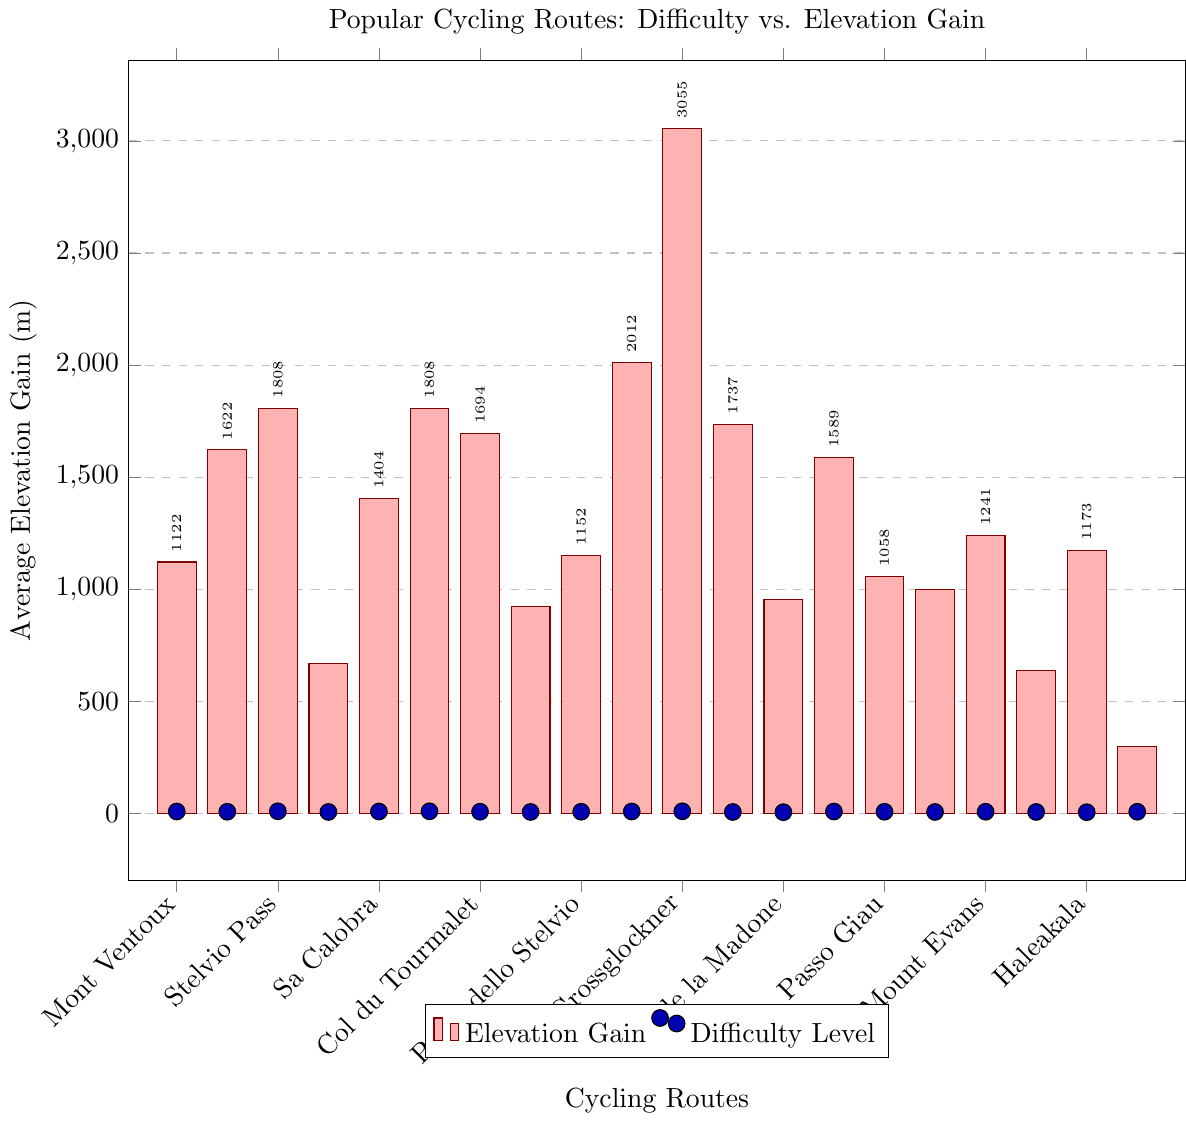What's the route with the highest average elevation gain? The route with the highest bar in the plot represents the highest average elevation gain. It is the “Haleakala” route marked with a height corresponding to 3055 meters.
Answer: Haleakala Which route has the least average elevation gain, and what is its difficulty level? The route with the smallest bar in the plot represents the least average elevation gain. This is the "Hardknott Pass" with an elevation gain of 298 meters. The associated mark shows a difficulty level of 8.
Answer: Hardknott Pass, 8 Compare the elevation gain of Mount Evans and Col de la Bonette. Which one has a higher elevation gain? By comparing the heights of the bars for Mount Evans and Col de la Bonette, Mount Evans has a higher elevation gain at 2012 meters compared to Col de la Bonette at 1589 meters.
Answer: Mount Evans What is the sum of the average elevation gains for the highest and lowest difficulty level routes? The highest difficulty level is 10, and has multiple routes: Stelvio Pass, Passo dello Stelvio, and Haleakala. We'll choose Haleakala for maximum elevation gain of 3055 meters. The lowest difficulty level represented is 6 with routes Axamer Lizum and Mount Diablo. We'll choose Mount Diablo with an elevation gain of 1173 meters. Sum = 3055 + 1173 = 4228 meters.
Answer: 4228 meters Which route with difficulty level 7 has the highest average elevation gain? Among the routes marked with a difficulty level of 7, the one with the tallest bar represents the highest elevation gain. Examining the plot, Mount Lemmon stands out with an elevation gain of 1737 meters.
Answer: Mount Lemmon Does the Stelvio Pass have the same elevation gain in both Italy and the specified one, and what is it? Observing the bars for "Stelvio Pass" and "Passo dello Stelvio" (both in Italy), both show the same elevation height, which is 1808 meters.
Answer: Yes, 1808 meters Compare the elevations of three routes with a difficulty level of 9 and identify the one with the lowest elevation gain. The three routes with a difficulty level of 9 are Alpe d'Huez, Col du Tourmalet, and Col de la Bonette. Their elevation gains are 1122m, 1404m, and 1589m respectively. Alpe d'Huez has the lowest elevation gain among them.
Answer: Alpe d'Huez For the route Grossglockner, what is the difference in meters between its elevation gain and the maximum elevation gain in the dataset? Grossglockner's elevation gain is 1694 meters. The maximum elevation gain in the dataset is Haleakala with 3055 meters. The difference is 3055 - 1694 = 1361 meters.
Answer: 1361 meters How many routes have an average elevation gain above 1600 meters, and what are their names? By examining the bars taller than the line marking 1600 meters, we find four routes: Mont Ventoux, Stelvio Pass (Italy), Mount Evans, Haleakala, and Mount Lemmon. Hence, there are five routes in total.
Answer: Five routes: Mont Ventoux, Stelvio Pass, Mount Evans, Haleakala, Mount Lemmon Which country has most frequently occurring routes in the plot and how many are there? Visual inspection of the X-axis labels shows that France has the most number of routes: Alpe d'Huez, Mont Ventoux, Col du Tourmalet, Col de la Madone, Col de la Bonette, Col d'Izoard. This counts to 6 routes.
Answer: France, 6 